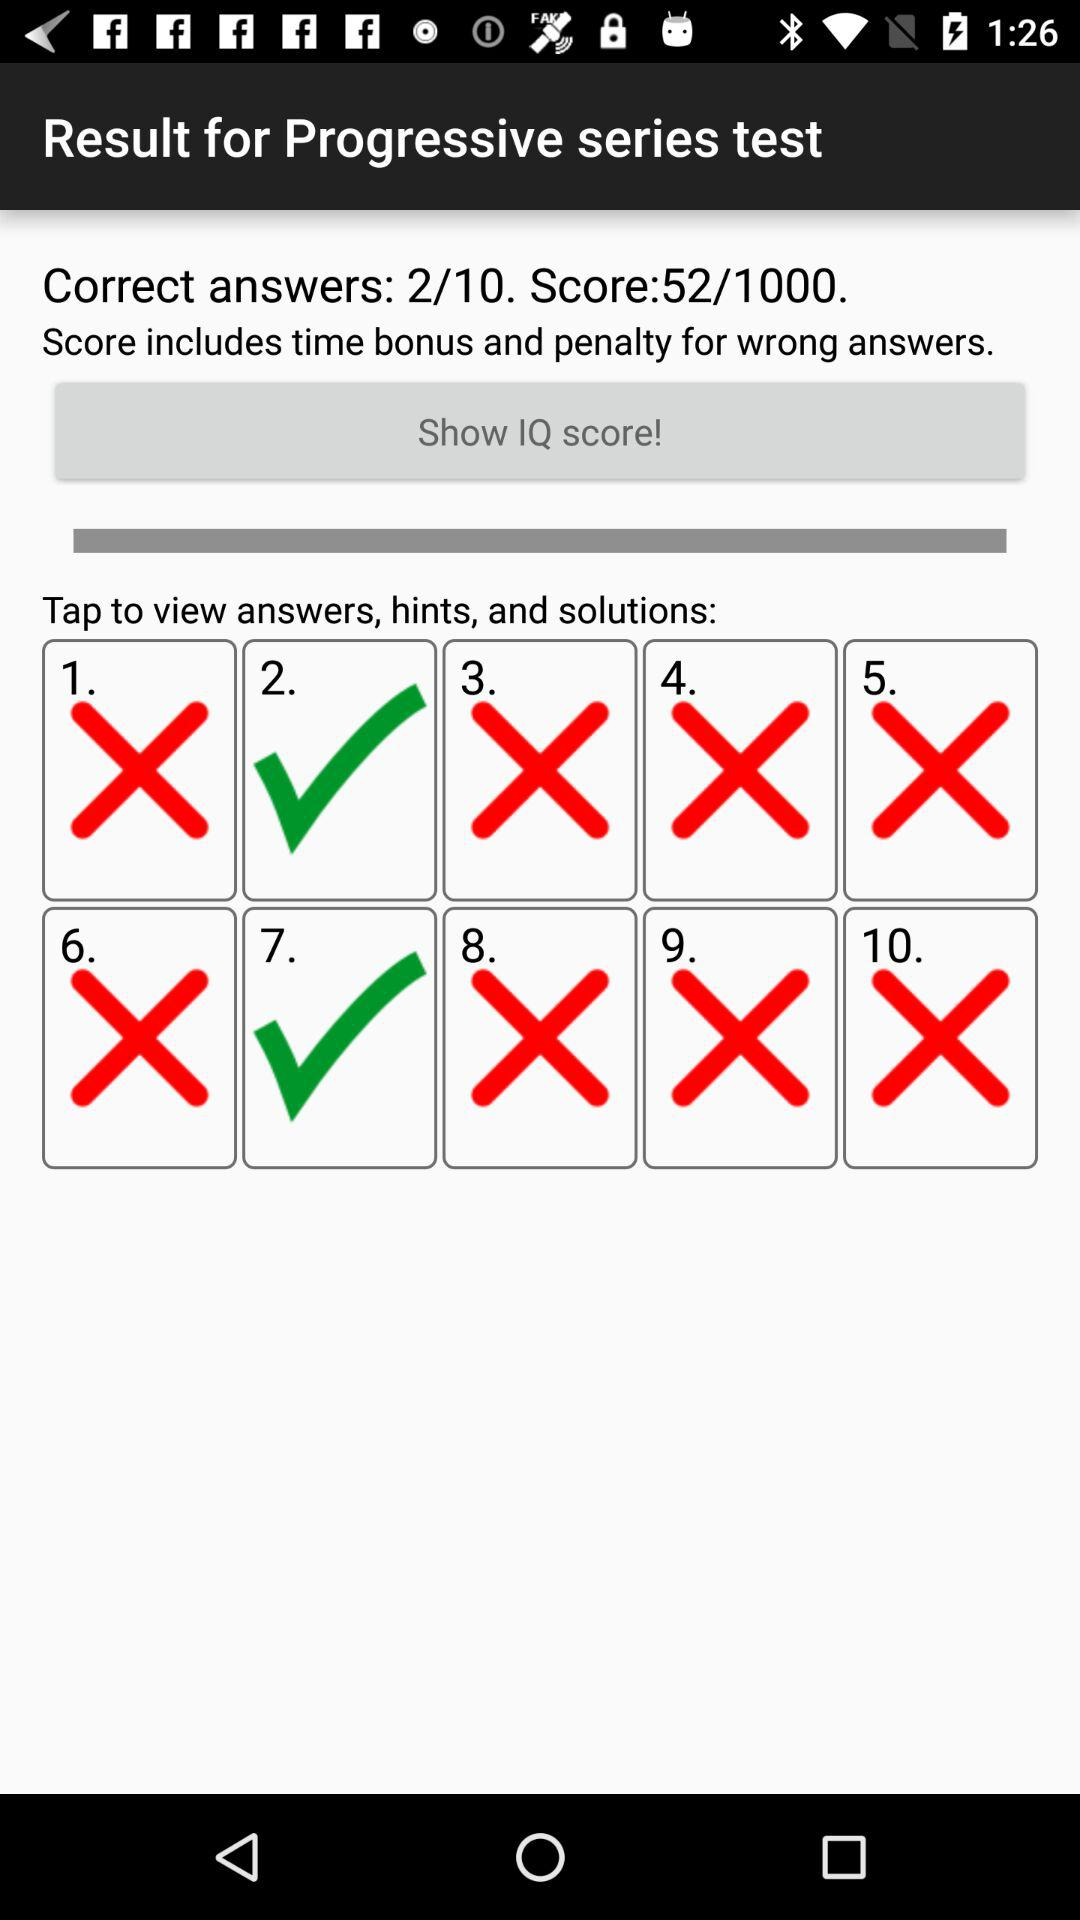What is the total number of questions? The total number of questions is 10. 